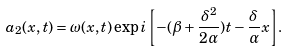Convert formula to latex. <formula><loc_0><loc_0><loc_500><loc_500>a _ { 2 } ( x , t ) = \omega ( x , t ) \exp { i \left [ - ( \beta + \frac { \delta ^ { 2 } } { 2 \alpha } ) t - \frac { \delta } { \alpha } x \right ] } .</formula> 